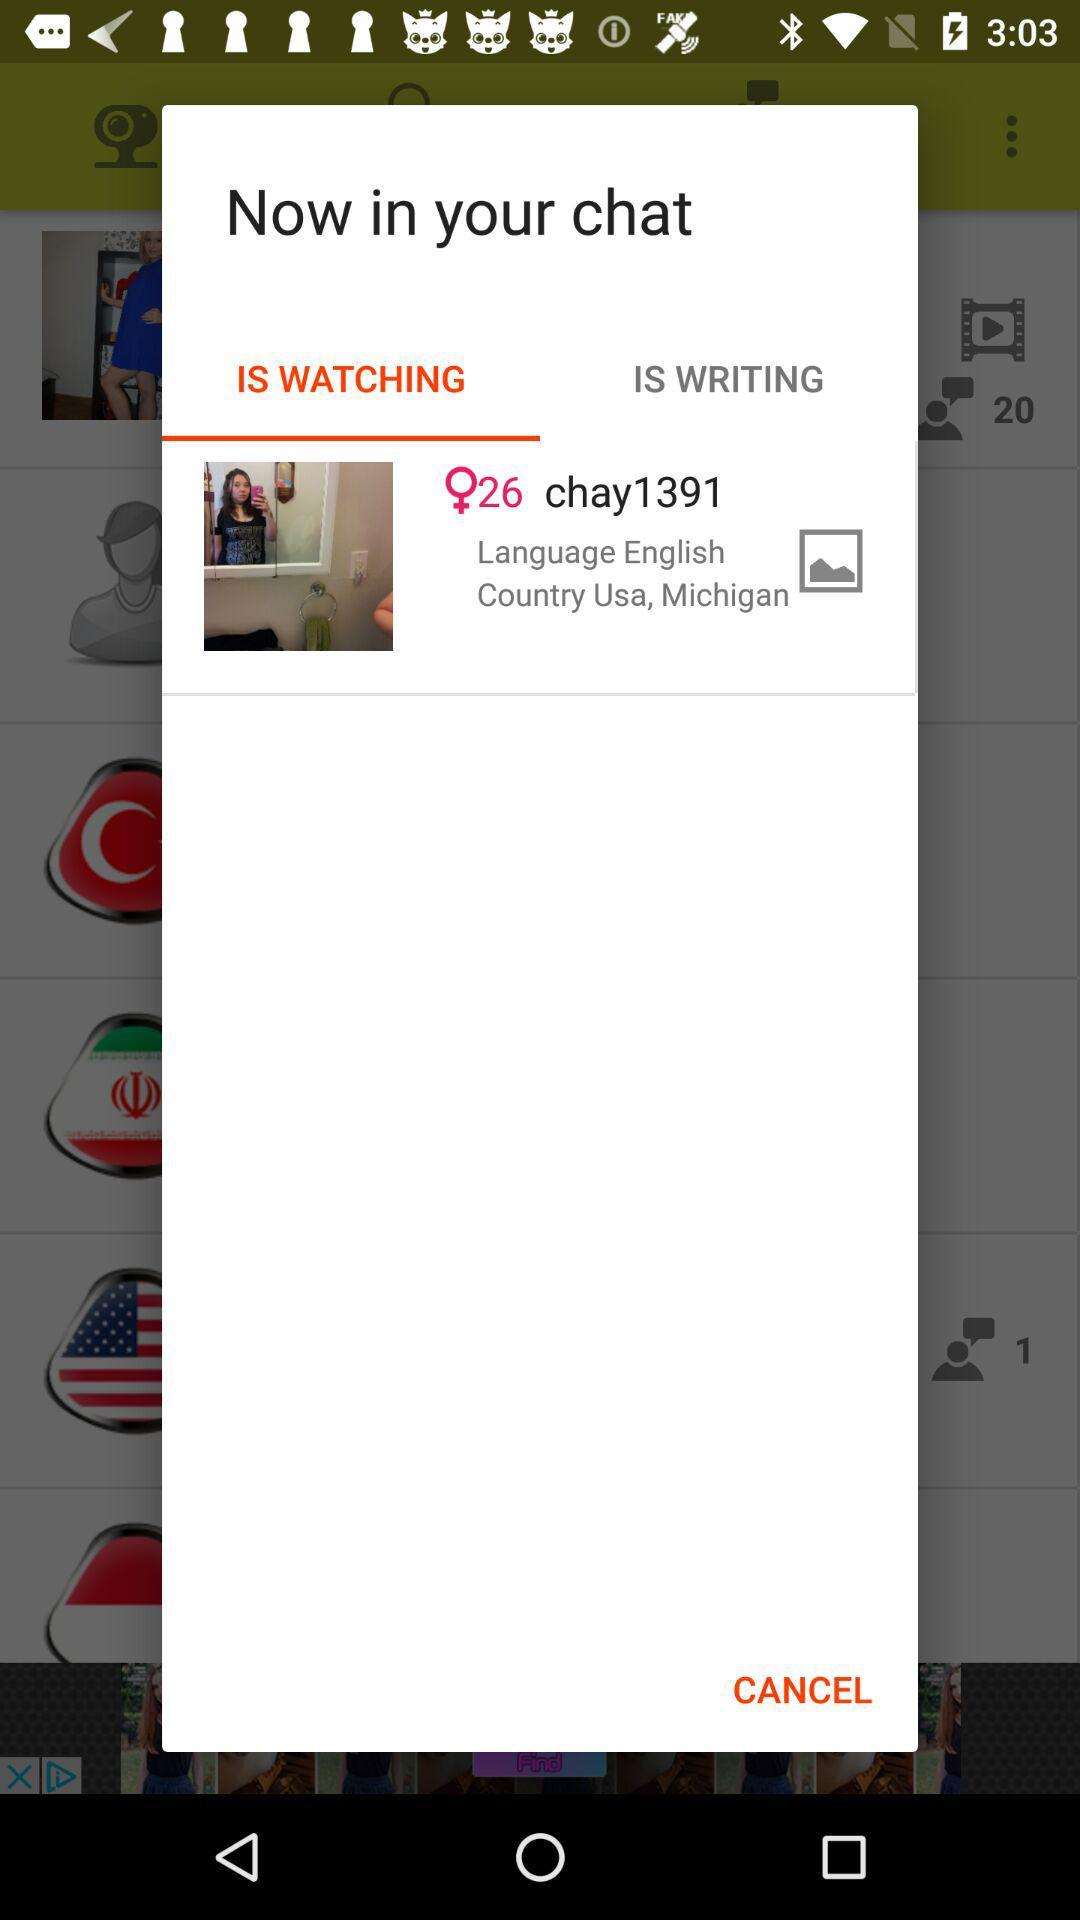What is the selected tab? The selected tab is "IS WATCHING". 